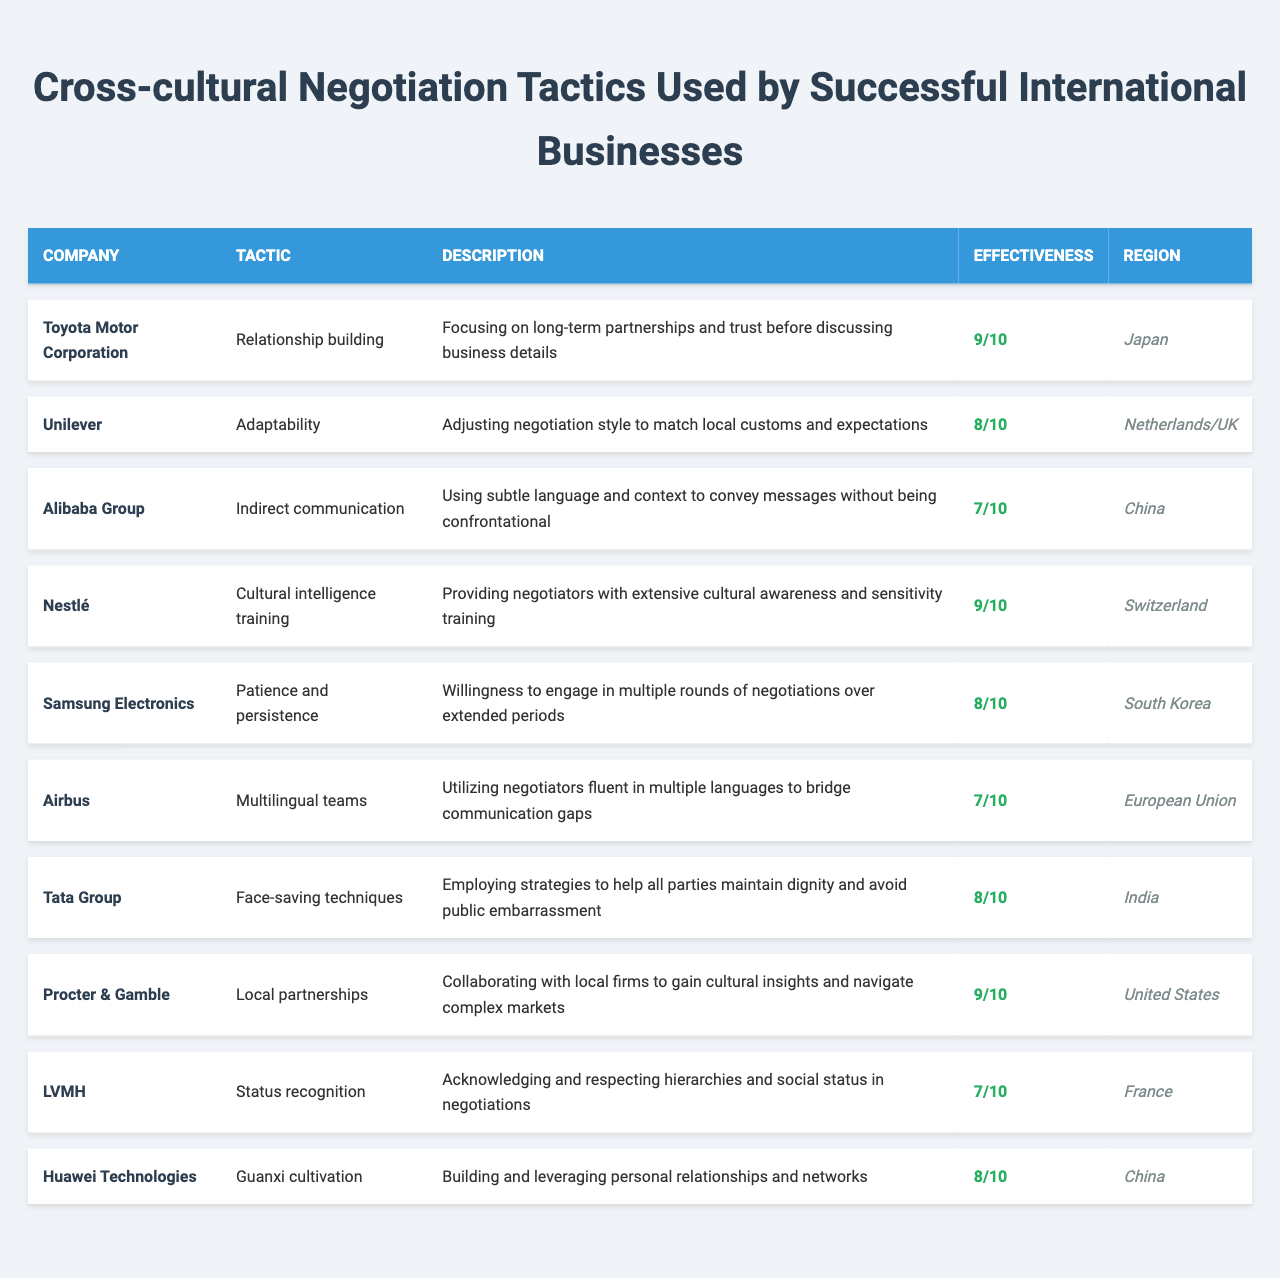What tactic is used by Toyota Motor Corporation? The table directly lists the tactic used by Toyota Motor Corporation as "Relationship building."
Answer: Relationship building Which company has an effectiveness rating of 9? Referring to the table, both Toyota Motor Corporation and Procter & Gamble have an effectiveness rating of 9.
Answer: Toyota Motor Corporation, Procter & Gamble What region is associated with Huawei Technologies' negotiation tactic? The table specifies that Huawei Technologies is associated with the region "China."
Answer: China How many companies use adaptability as a negotiation tactic? By inspecting the table, it can be noted that only Unilever employs adaptability as a negotiation tactic.
Answer: One company What is the average effectiveness rating of the companies listed? Summing all effectiveness ratings gives 9 + 8 + 7 + 9 + 8 + 7 + 8 + 9 + 7 + 8 = 80, and there are 10 companies, so the average is 80/10 = 8.
Answer: 8 Is it true that Nestlé employs indirect communication as a tactic? The table shows that Nestlé uses "Cultural intelligence training" and not indirect communication, indicating that the statement is false.
Answer: False Which tactic has a higher effectiveness rating, face-saving techniques or status recognition? Comparing the effectiveness ratings, face-saving techniques (8) is higher than status recognition (7).
Answer: Face-saving techniques What company uses "Guanxi cultivation" in their negotiations? Referring to the table, Huawei Technologies is the company that uses "Guanxi cultivation" in their negotiations.
Answer: Huawei Technologies What is the effectiveness rating for Airbus and how does it compare to that of Samsung Electronics? Airbus has an effectiveness rating of 7, while Samsung Electronics has a rating of 8. Thus, Samsung Electronics is rated higher than Airbus by 1 point.
Answer: Airbus: 7, Samsung Electronics: 8 Count how many tactics score 8 or above in effectiveness. There are 5 tactics rated 8 or above: Toyota Motor Corporation (9), Nestlé (9), Procter & Gamble (9), Samsung Electronics (8), and Tata Group (8).
Answer: 5 